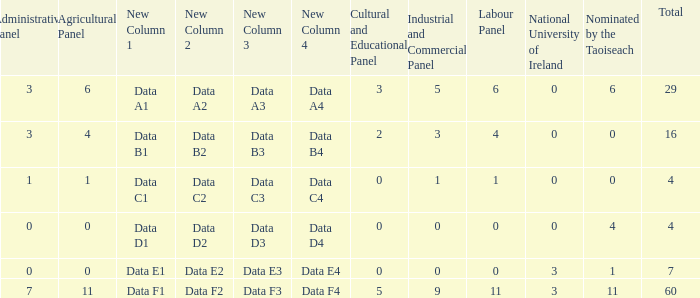What is the total number of agriculatural panels of the composition with more than 3 National Universities of Ireland? 0.0. 